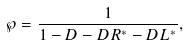Convert formula to latex. <formula><loc_0><loc_0><loc_500><loc_500>\wp = \frac { 1 } { 1 - D - D R ^ { * } - D L ^ { * } } ,</formula> 